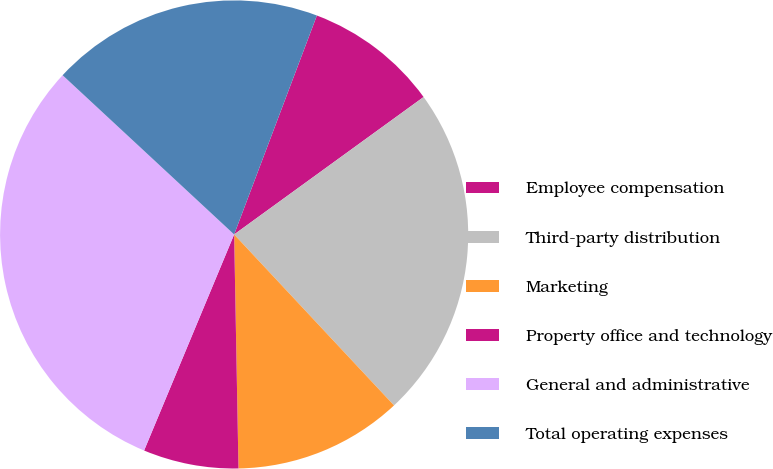<chart> <loc_0><loc_0><loc_500><loc_500><pie_chart><fcel>Employee compensation<fcel>Third-party distribution<fcel>Marketing<fcel>Property office and technology<fcel>General and administrative<fcel>Total operating expenses<nl><fcel>9.26%<fcel>23.02%<fcel>11.67%<fcel>6.58%<fcel>30.62%<fcel>18.84%<nl></chart> 